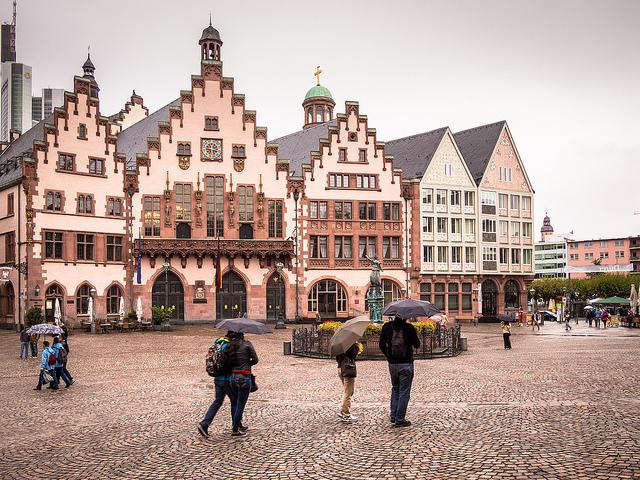Is it a sunny day?
Short answer required. No. What are the people holding?
Give a very brief answer. Umbrellas. What is the street made of?
Quick response, please. Brick. 